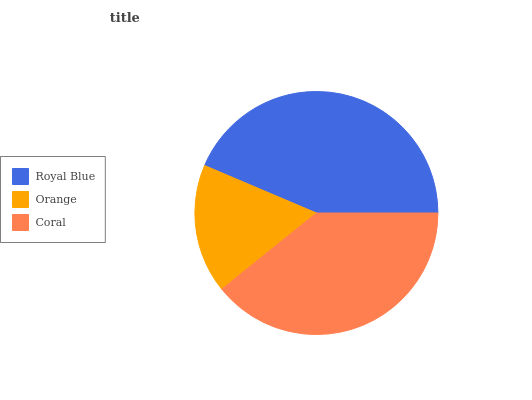Is Orange the minimum?
Answer yes or no. Yes. Is Royal Blue the maximum?
Answer yes or no. Yes. Is Coral the minimum?
Answer yes or no. No. Is Coral the maximum?
Answer yes or no. No. Is Coral greater than Orange?
Answer yes or no. Yes. Is Orange less than Coral?
Answer yes or no. Yes. Is Orange greater than Coral?
Answer yes or no. No. Is Coral less than Orange?
Answer yes or no. No. Is Coral the high median?
Answer yes or no. Yes. Is Coral the low median?
Answer yes or no. Yes. Is Royal Blue the high median?
Answer yes or no. No. Is Orange the low median?
Answer yes or no. No. 